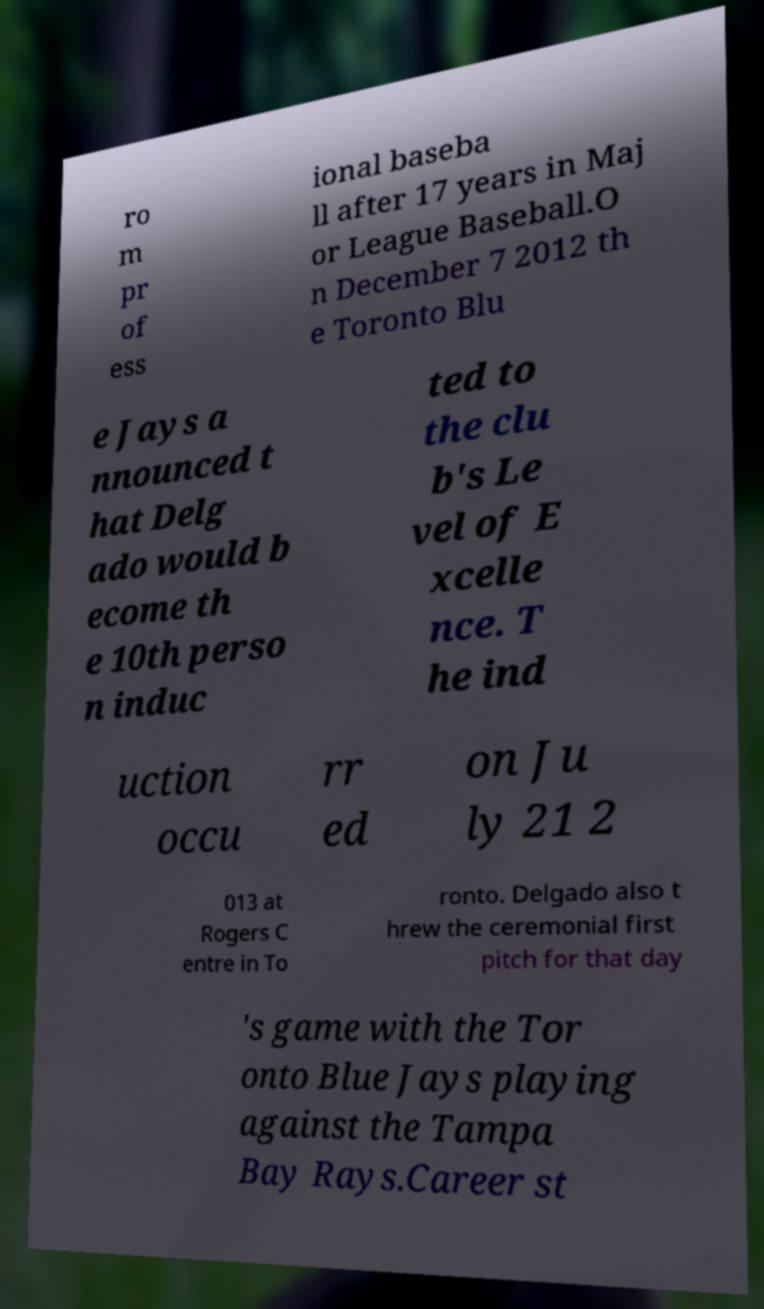Can you accurately transcribe the text from the provided image for me? ro m pr of ess ional baseba ll after 17 years in Maj or League Baseball.O n December 7 2012 th e Toronto Blu e Jays a nnounced t hat Delg ado would b ecome th e 10th perso n induc ted to the clu b's Le vel of E xcelle nce. T he ind uction occu rr ed on Ju ly 21 2 013 at Rogers C entre in To ronto. Delgado also t hrew the ceremonial first pitch for that day 's game with the Tor onto Blue Jays playing against the Tampa Bay Rays.Career st 